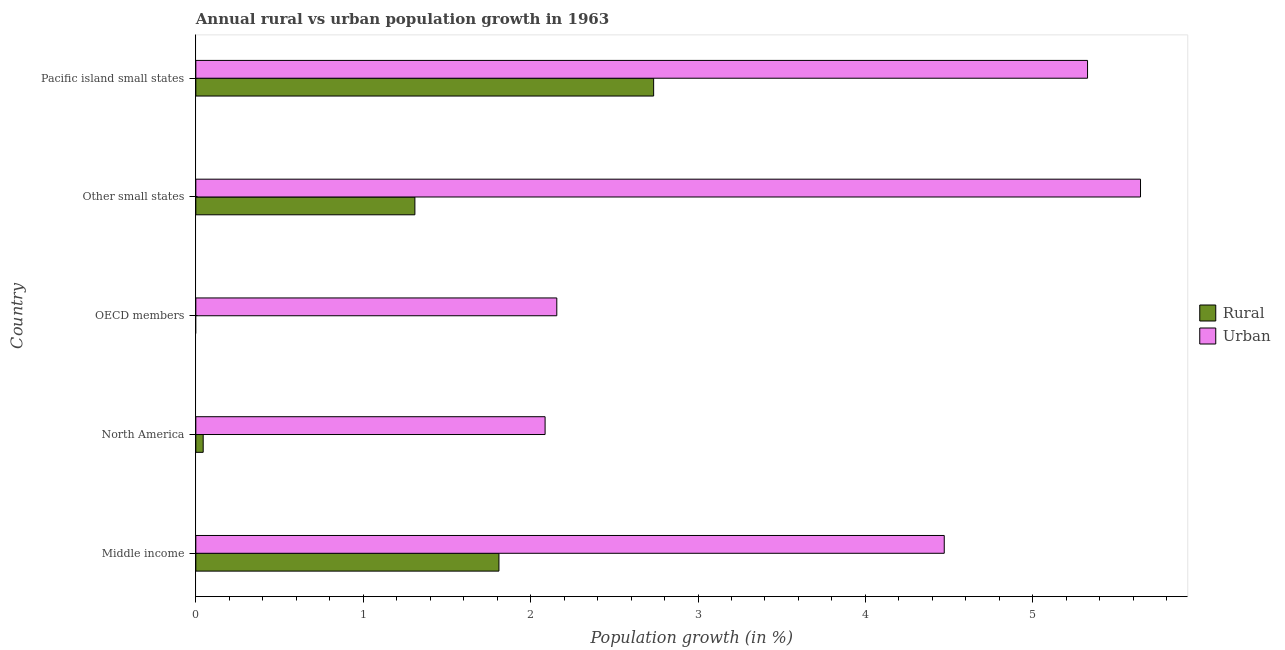How many different coloured bars are there?
Provide a short and direct response. 2. How many bars are there on the 3rd tick from the bottom?
Your answer should be compact. 1. What is the label of the 2nd group of bars from the top?
Provide a succinct answer. Other small states. In how many cases, is the number of bars for a given country not equal to the number of legend labels?
Provide a short and direct response. 1. What is the rural population growth in North America?
Your response must be concise. 0.04. Across all countries, what is the maximum rural population growth?
Your answer should be very brief. 2.73. Across all countries, what is the minimum rural population growth?
Give a very brief answer. 0. In which country was the rural population growth maximum?
Your answer should be very brief. Pacific island small states. What is the total urban population growth in the graph?
Offer a very short reply. 19.68. What is the difference between the rural population growth in Middle income and that in Other small states?
Your response must be concise. 0.5. What is the difference between the urban population growth in Pacific island small states and the rural population growth in OECD members?
Provide a succinct answer. 5.33. What is the average rural population growth per country?
Your response must be concise. 1.18. What is the difference between the urban population growth and rural population growth in Pacific island small states?
Provide a succinct answer. 2.59. What is the ratio of the urban population growth in OECD members to that in Pacific island small states?
Provide a short and direct response. 0.41. Is the urban population growth in Other small states less than that in Pacific island small states?
Provide a short and direct response. No. Is the difference between the rural population growth in North America and Pacific island small states greater than the difference between the urban population growth in North America and Pacific island small states?
Ensure brevity in your answer.  Yes. What is the difference between the highest and the second highest rural population growth?
Your answer should be very brief. 0.92. What is the difference between the highest and the lowest urban population growth?
Keep it short and to the point. 3.56. Is the sum of the rural population growth in Middle income and Pacific island small states greater than the maximum urban population growth across all countries?
Provide a succinct answer. No. How many bars are there?
Provide a short and direct response. 9. How many countries are there in the graph?
Give a very brief answer. 5. Are the values on the major ticks of X-axis written in scientific E-notation?
Provide a short and direct response. No. Does the graph contain any zero values?
Offer a terse response. Yes. Does the graph contain grids?
Keep it short and to the point. No. Where does the legend appear in the graph?
Provide a short and direct response. Center right. How many legend labels are there?
Your response must be concise. 2. How are the legend labels stacked?
Provide a short and direct response. Vertical. What is the title of the graph?
Keep it short and to the point. Annual rural vs urban population growth in 1963. What is the label or title of the X-axis?
Your answer should be compact. Population growth (in %). What is the Population growth (in %) of Rural in Middle income?
Offer a terse response. 1.81. What is the Population growth (in %) in Urban  in Middle income?
Keep it short and to the point. 4.47. What is the Population growth (in %) of Rural in North America?
Your answer should be very brief. 0.04. What is the Population growth (in %) of Urban  in North America?
Your response must be concise. 2.09. What is the Population growth (in %) of Urban  in OECD members?
Give a very brief answer. 2.16. What is the Population growth (in %) of Rural in Other small states?
Your answer should be compact. 1.31. What is the Population growth (in %) of Urban  in Other small states?
Provide a succinct answer. 5.64. What is the Population growth (in %) of Rural in Pacific island small states?
Your response must be concise. 2.73. What is the Population growth (in %) of Urban  in Pacific island small states?
Keep it short and to the point. 5.33. Across all countries, what is the maximum Population growth (in %) in Rural?
Your answer should be very brief. 2.73. Across all countries, what is the maximum Population growth (in %) in Urban ?
Keep it short and to the point. 5.64. Across all countries, what is the minimum Population growth (in %) in Rural?
Your answer should be compact. 0. Across all countries, what is the minimum Population growth (in %) of Urban ?
Ensure brevity in your answer.  2.09. What is the total Population growth (in %) of Rural in the graph?
Offer a terse response. 5.9. What is the total Population growth (in %) of Urban  in the graph?
Provide a short and direct response. 19.68. What is the difference between the Population growth (in %) of Rural in Middle income and that in North America?
Your answer should be very brief. 1.77. What is the difference between the Population growth (in %) of Urban  in Middle income and that in North America?
Your response must be concise. 2.38. What is the difference between the Population growth (in %) in Urban  in Middle income and that in OECD members?
Your answer should be compact. 2.31. What is the difference between the Population growth (in %) of Rural in Middle income and that in Other small states?
Your answer should be compact. 0.5. What is the difference between the Population growth (in %) in Urban  in Middle income and that in Other small states?
Ensure brevity in your answer.  -1.17. What is the difference between the Population growth (in %) in Rural in Middle income and that in Pacific island small states?
Offer a very short reply. -0.92. What is the difference between the Population growth (in %) in Urban  in Middle income and that in Pacific island small states?
Make the answer very short. -0.86. What is the difference between the Population growth (in %) of Urban  in North America and that in OECD members?
Provide a short and direct response. -0.07. What is the difference between the Population growth (in %) in Rural in North America and that in Other small states?
Ensure brevity in your answer.  -1.26. What is the difference between the Population growth (in %) of Urban  in North America and that in Other small states?
Make the answer very short. -3.56. What is the difference between the Population growth (in %) in Rural in North America and that in Pacific island small states?
Keep it short and to the point. -2.69. What is the difference between the Population growth (in %) of Urban  in North America and that in Pacific island small states?
Your response must be concise. -3.24. What is the difference between the Population growth (in %) in Urban  in OECD members and that in Other small states?
Offer a terse response. -3.49. What is the difference between the Population growth (in %) in Urban  in OECD members and that in Pacific island small states?
Offer a very short reply. -3.17. What is the difference between the Population growth (in %) of Rural in Other small states and that in Pacific island small states?
Your response must be concise. -1.43. What is the difference between the Population growth (in %) of Urban  in Other small states and that in Pacific island small states?
Your answer should be compact. 0.32. What is the difference between the Population growth (in %) of Rural in Middle income and the Population growth (in %) of Urban  in North America?
Make the answer very short. -0.28. What is the difference between the Population growth (in %) of Rural in Middle income and the Population growth (in %) of Urban  in OECD members?
Ensure brevity in your answer.  -0.35. What is the difference between the Population growth (in %) in Rural in Middle income and the Population growth (in %) in Urban  in Other small states?
Your answer should be compact. -3.83. What is the difference between the Population growth (in %) in Rural in Middle income and the Population growth (in %) in Urban  in Pacific island small states?
Your response must be concise. -3.52. What is the difference between the Population growth (in %) in Rural in North America and the Population growth (in %) in Urban  in OECD members?
Make the answer very short. -2.11. What is the difference between the Population growth (in %) in Rural in North America and the Population growth (in %) in Urban  in Other small states?
Ensure brevity in your answer.  -5.6. What is the difference between the Population growth (in %) in Rural in North America and the Population growth (in %) in Urban  in Pacific island small states?
Offer a terse response. -5.28. What is the difference between the Population growth (in %) of Rural in Other small states and the Population growth (in %) of Urban  in Pacific island small states?
Make the answer very short. -4.02. What is the average Population growth (in %) in Rural per country?
Provide a succinct answer. 1.18. What is the average Population growth (in %) in Urban  per country?
Give a very brief answer. 3.94. What is the difference between the Population growth (in %) in Rural and Population growth (in %) in Urban  in Middle income?
Offer a very short reply. -2.66. What is the difference between the Population growth (in %) of Rural and Population growth (in %) of Urban  in North America?
Make the answer very short. -2.04. What is the difference between the Population growth (in %) of Rural and Population growth (in %) of Urban  in Other small states?
Your response must be concise. -4.33. What is the difference between the Population growth (in %) of Rural and Population growth (in %) of Urban  in Pacific island small states?
Provide a succinct answer. -2.59. What is the ratio of the Population growth (in %) of Rural in Middle income to that in North America?
Provide a short and direct response. 41.21. What is the ratio of the Population growth (in %) in Urban  in Middle income to that in North America?
Your answer should be compact. 2.14. What is the ratio of the Population growth (in %) in Urban  in Middle income to that in OECD members?
Ensure brevity in your answer.  2.07. What is the ratio of the Population growth (in %) in Rural in Middle income to that in Other small states?
Ensure brevity in your answer.  1.38. What is the ratio of the Population growth (in %) of Urban  in Middle income to that in Other small states?
Provide a short and direct response. 0.79. What is the ratio of the Population growth (in %) of Rural in Middle income to that in Pacific island small states?
Offer a very short reply. 0.66. What is the ratio of the Population growth (in %) in Urban  in Middle income to that in Pacific island small states?
Provide a succinct answer. 0.84. What is the ratio of the Population growth (in %) of Urban  in North America to that in OECD members?
Make the answer very short. 0.97. What is the ratio of the Population growth (in %) of Rural in North America to that in Other small states?
Provide a succinct answer. 0.03. What is the ratio of the Population growth (in %) of Urban  in North America to that in Other small states?
Give a very brief answer. 0.37. What is the ratio of the Population growth (in %) in Rural in North America to that in Pacific island small states?
Your answer should be very brief. 0.02. What is the ratio of the Population growth (in %) in Urban  in North America to that in Pacific island small states?
Offer a terse response. 0.39. What is the ratio of the Population growth (in %) of Urban  in OECD members to that in Other small states?
Give a very brief answer. 0.38. What is the ratio of the Population growth (in %) in Urban  in OECD members to that in Pacific island small states?
Your answer should be compact. 0.4. What is the ratio of the Population growth (in %) of Rural in Other small states to that in Pacific island small states?
Your response must be concise. 0.48. What is the ratio of the Population growth (in %) of Urban  in Other small states to that in Pacific island small states?
Your answer should be very brief. 1.06. What is the difference between the highest and the second highest Population growth (in %) of Rural?
Offer a terse response. 0.92. What is the difference between the highest and the second highest Population growth (in %) of Urban ?
Your answer should be compact. 0.32. What is the difference between the highest and the lowest Population growth (in %) in Rural?
Offer a very short reply. 2.73. What is the difference between the highest and the lowest Population growth (in %) of Urban ?
Provide a succinct answer. 3.56. 